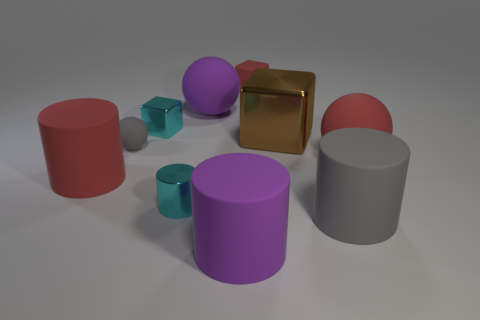Do the small gray sphere and the big thing on the left side of the small sphere have the same material? Yes, the small gray sphere and the larger object to its left appear to have the same matte finish, suggesting they are likely made of a similar material. This material could be a type of plastic or metal, considering the light reflection and texture observed. 